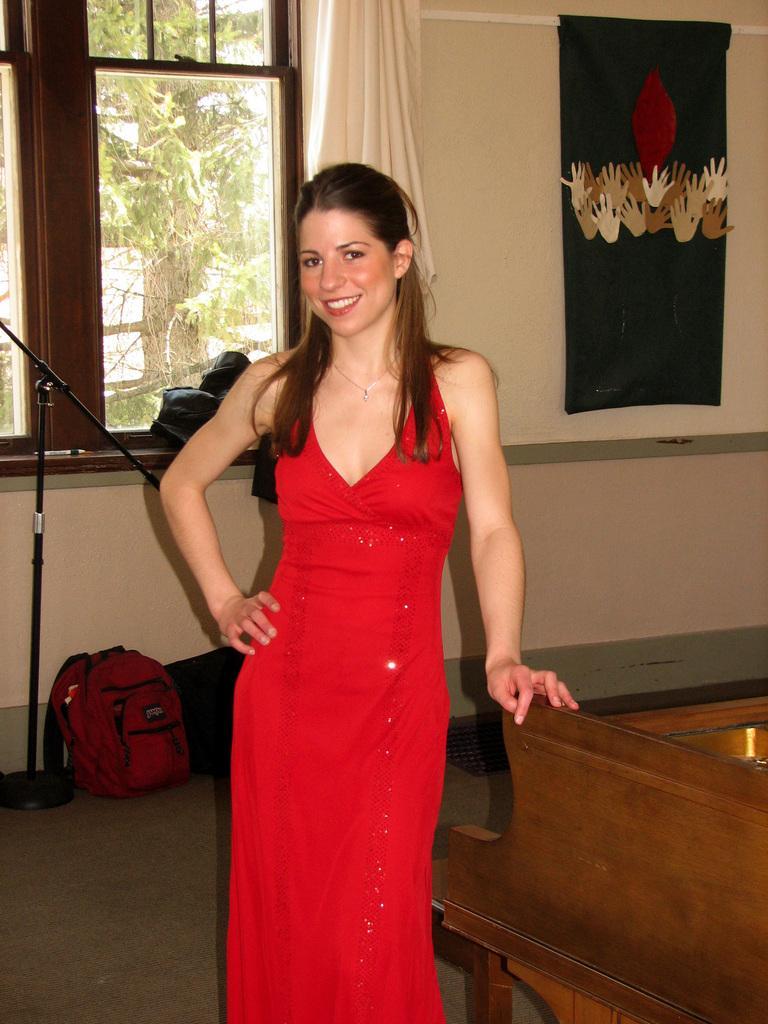Please provide a concise description of this image. In the image there is a woman,she wore red dress ,she kept her hand on piano and the background there is curtain and window,outside the window there is tree and down the window on floor there is a bag. 